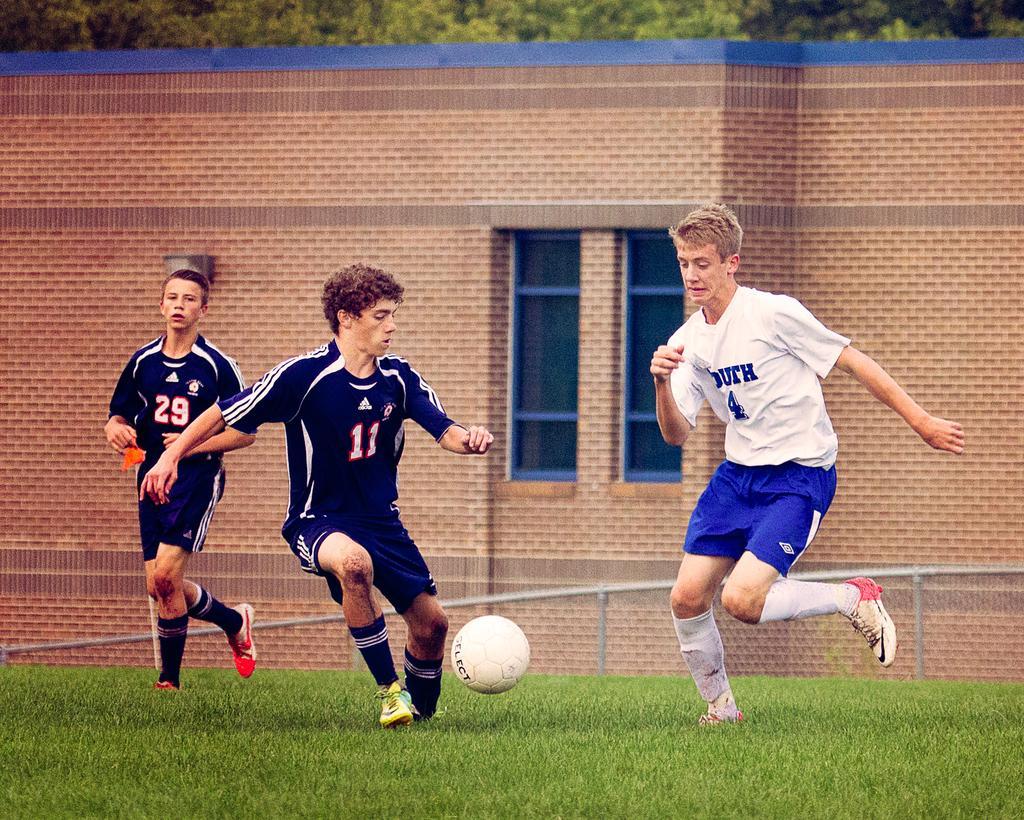Can you describe this image briefly? In this image there are people playing football. At the bottom of the image there is grass on the surface. In the background of the image there is a metal fence. there is a building. There are trees. 